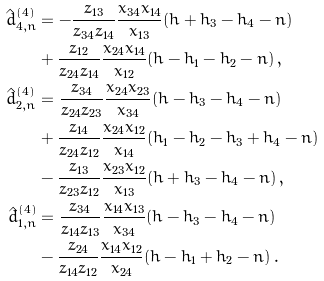Convert formula to latex. <formula><loc_0><loc_0><loc_500><loc_500>\hat { d } ^ { ( 4 ) } _ { 4 , n } & = - \frac { z _ { 1 3 } } { z _ { 3 4 } z _ { 1 4 } } \frac { x _ { 3 4 } x _ { 1 4 } } { x _ { 1 3 } } ( h + h _ { 3 } - h _ { 4 } - n ) \\ & + \frac { z _ { 1 2 } } { z _ { 2 4 } z _ { 1 4 } } \frac { x _ { 2 4 } x _ { 1 4 } } { x _ { 1 2 } } ( h - h _ { 1 } - h _ { 2 } - n ) \, , \\ \hat { d } ^ { ( 4 ) } _ { 2 , n } & = \frac { z _ { 3 4 } } { z _ { 2 4 } z _ { 2 3 } } \frac { x _ { 2 4 } x _ { 2 3 } } { x _ { 3 4 } } ( h - h _ { 3 } - h _ { 4 } - n ) \\ & + \frac { z _ { 1 4 } } { z _ { 2 4 } z _ { 1 2 } } \frac { x _ { 2 4 } x _ { 1 2 } } { x _ { 1 4 } } ( h _ { 1 } - h _ { 2 } - h _ { 3 } + h _ { 4 } - n ) \\ & - \frac { z _ { 1 3 } } { z _ { 2 3 } z _ { 1 2 } } \frac { x _ { 2 3 } x _ { 1 2 } } { x _ { 1 3 } } ( h + h _ { 3 } - h _ { 4 } - n ) \, , \\ \hat { d } ^ { ( 4 ) } _ { 1 , n } & = \frac { z _ { 3 4 } } { z _ { 1 4 } z _ { 1 3 } } \frac { x _ { 1 4 } x _ { 1 3 } } { x _ { 3 4 } } ( h - h _ { 3 } - h _ { 4 } - n ) \, \\ & - \frac { z _ { 2 4 } } { z _ { 1 4 } z _ { 1 2 } } \frac { x _ { 1 4 } x _ { 1 2 } } { x _ { 2 4 } } ( h - h _ { 1 } + h _ { 2 } - n ) \, .</formula> 